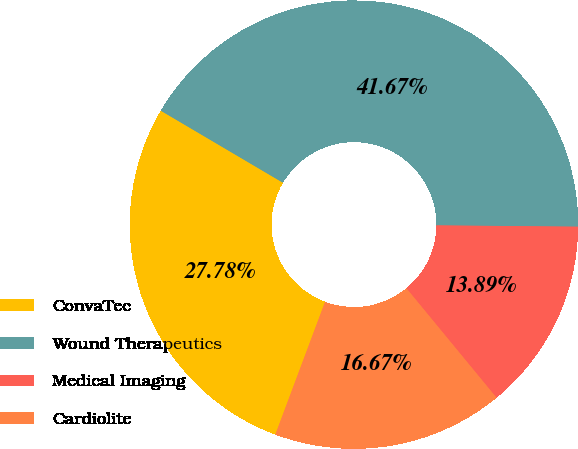Convert chart. <chart><loc_0><loc_0><loc_500><loc_500><pie_chart><fcel>ConvaTec<fcel>Wound Therapeutics<fcel>Medical Imaging<fcel>Cardiolite<nl><fcel>27.78%<fcel>41.67%<fcel>13.89%<fcel>16.67%<nl></chart> 